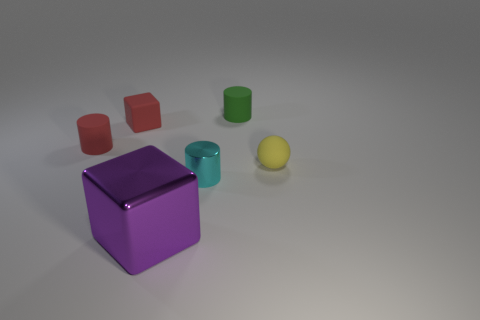Add 4 tiny cyan objects. How many objects exist? 10 Subtract all blocks. How many objects are left? 4 Add 3 purple metallic cubes. How many purple metallic cubes exist? 4 Subtract 1 red cubes. How many objects are left? 5 Subtract all large objects. Subtract all purple objects. How many objects are left? 4 Add 1 tiny cyan metal cylinders. How many tiny cyan metal cylinders are left? 2 